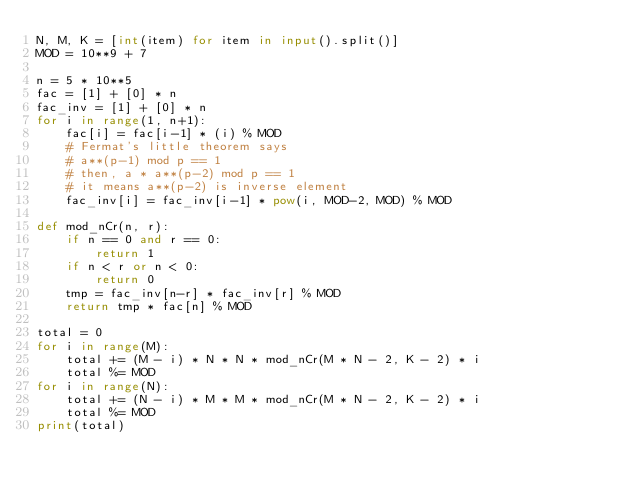<code> <loc_0><loc_0><loc_500><loc_500><_Python_>N, M, K = [int(item) for item in input().split()]
MOD = 10**9 + 7

n = 5 * 10**5 
fac = [1] + [0] * n
fac_inv = [1] + [0] * n
for i in range(1, n+1):
    fac[i] = fac[i-1] * (i) % MOD
    # Fermat's little theorem says
    # a**(p-1) mod p == 1
    # then, a * a**(p-2) mod p == 1
    # it means a**(p-2) is inverse element
    fac_inv[i] = fac_inv[i-1] * pow(i, MOD-2, MOD) % MOD

def mod_nCr(n, r):
    if n == 0 and r == 0:
        return 1
    if n < r or n < 0:
        return 0
    tmp = fac_inv[n-r] * fac_inv[r] % MOD
    return tmp * fac[n] % MOD 

total = 0
for i in range(M):
    total += (M - i) * N * N * mod_nCr(M * N - 2, K - 2) * i
    total %= MOD  
for i in range(N):
    total += (N - i) * M * M * mod_nCr(M * N - 2, K - 2) * i
    total %= MOD  
print(total)</code> 